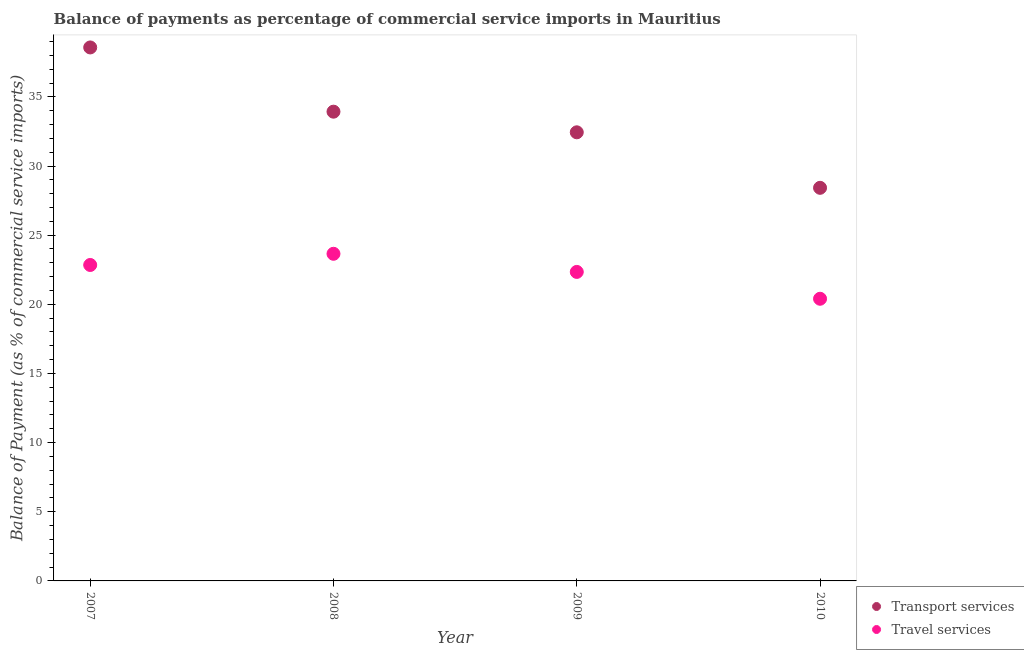How many different coloured dotlines are there?
Keep it short and to the point. 2. What is the balance of payments of travel services in 2008?
Provide a succinct answer. 23.65. Across all years, what is the maximum balance of payments of transport services?
Ensure brevity in your answer.  38.57. Across all years, what is the minimum balance of payments of transport services?
Your answer should be compact. 28.42. What is the total balance of payments of transport services in the graph?
Give a very brief answer. 133.36. What is the difference between the balance of payments of travel services in 2008 and that in 2009?
Offer a very short reply. 1.31. What is the difference between the balance of payments of travel services in 2007 and the balance of payments of transport services in 2008?
Keep it short and to the point. -11.08. What is the average balance of payments of transport services per year?
Keep it short and to the point. 33.34. In the year 2009, what is the difference between the balance of payments of travel services and balance of payments of transport services?
Give a very brief answer. -10.09. In how many years, is the balance of payments of transport services greater than 9 %?
Make the answer very short. 4. What is the ratio of the balance of payments of transport services in 2007 to that in 2009?
Make the answer very short. 1.19. What is the difference between the highest and the second highest balance of payments of travel services?
Keep it short and to the point. 0.81. What is the difference between the highest and the lowest balance of payments of travel services?
Provide a succinct answer. 3.25. In how many years, is the balance of payments of travel services greater than the average balance of payments of travel services taken over all years?
Offer a terse response. 3. How many dotlines are there?
Make the answer very short. 2. How many years are there in the graph?
Provide a succinct answer. 4. Are the values on the major ticks of Y-axis written in scientific E-notation?
Your response must be concise. No. How many legend labels are there?
Your answer should be compact. 2. How are the legend labels stacked?
Make the answer very short. Vertical. What is the title of the graph?
Offer a very short reply. Balance of payments as percentage of commercial service imports in Mauritius. Does "Methane" appear as one of the legend labels in the graph?
Your response must be concise. No. What is the label or title of the Y-axis?
Keep it short and to the point. Balance of Payment (as % of commercial service imports). What is the Balance of Payment (as % of commercial service imports) of Transport services in 2007?
Make the answer very short. 38.57. What is the Balance of Payment (as % of commercial service imports) in Travel services in 2007?
Ensure brevity in your answer.  22.84. What is the Balance of Payment (as % of commercial service imports) in Transport services in 2008?
Offer a terse response. 33.93. What is the Balance of Payment (as % of commercial service imports) of Travel services in 2008?
Ensure brevity in your answer.  23.65. What is the Balance of Payment (as % of commercial service imports) of Transport services in 2009?
Your answer should be very brief. 32.44. What is the Balance of Payment (as % of commercial service imports) of Travel services in 2009?
Provide a succinct answer. 22.34. What is the Balance of Payment (as % of commercial service imports) of Transport services in 2010?
Your response must be concise. 28.42. What is the Balance of Payment (as % of commercial service imports) in Travel services in 2010?
Offer a very short reply. 20.4. Across all years, what is the maximum Balance of Payment (as % of commercial service imports) in Transport services?
Your answer should be compact. 38.57. Across all years, what is the maximum Balance of Payment (as % of commercial service imports) in Travel services?
Your answer should be compact. 23.65. Across all years, what is the minimum Balance of Payment (as % of commercial service imports) of Transport services?
Offer a terse response. 28.42. Across all years, what is the minimum Balance of Payment (as % of commercial service imports) in Travel services?
Give a very brief answer. 20.4. What is the total Balance of Payment (as % of commercial service imports) in Transport services in the graph?
Your answer should be compact. 133.36. What is the total Balance of Payment (as % of commercial service imports) of Travel services in the graph?
Your answer should be compact. 89.24. What is the difference between the Balance of Payment (as % of commercial service imports) in Transport services in 2007 and that in 2008?
Ensure brevity in your answer.  4.64. What is the difference between the Balance of Payment (as % of commercial service imports) in Travel services in 2007 and that in 2008?
Give a very brief answer. -0.81. What is the difference between the Balance of Payment (as % of commercial service imports) in Transport services in 2007 and that in 2009?
Your answer should be very brief. 6.14. What is the difference between the Balance of Payment (as % of commercial service imports) in Travel services in 2007 and that in 2009?
Provide a short and direct response. 0.5. What is the difference between the Balance of Payment (as % of commercial service imports) of Transport services in 2007 and that in 2010?
Offer a very short reply. 10.15. What is the difference between the Balance of Payment (as % of commercial service imports) of Travel services in 2007 and that in 2010?
Ensure brevity in your answer.  2.44. What is the difference between the Balance of Payment (as % of commercial service imports) of Transport services in 2008 and that in 2009?
Make the answer very short. 1.49. What is the difference between the Balance of Payment (as % of commercial service imports) in Travel services in 2008 and that in 2009?
Offer a very short reply. 1.31. What is the difference between the Balance of Payment (as % of commercial service imports) of Transport services in 2008 and that in 2010?
Give a very brief answer. 5.51. What is the difference between the Balance of Payment (as % of commercial service imports) in Travel services in 2008 and that in 2010?
Provide a short and direct response. 3.25. What is the difference between the Balance of Payment (as % of commercial service imports) of Transport services in 2009 and that in 2010?
Your answer should be compact. 4.01. What is the difference between the Balance of Payment (as % of commercial service imports) of Travel services in 2009 and that in 2010?
Provide a short and direct response. 1.94. What is the difference between the Balance of Payment (as % of commercial service imports) in Transport services in 2007 and the Balance of Payment (as % of commercial service imports) in Travel services in 2008?
Provide a short and direct response. 14.92. What is the difference between the Balance of Payment (as % of commercial service imports) in Transport services in 2007 and the Balance of Payment (as % of commercial service imports) in Travel services in 2009?
Offer a terse response. 16.23. What is the difference between the Balance of Payment (as % of commercial service imports) of Transport services in 2007 and the Balance of Payment (as % of commercial service imports) of Travel services in 2010?
Offer a terse response. 18.17. What is the difference between the Balance of Payment (as % of commercial service imports) in Transport services in 2008 and the Balance of Payment (as % of commercial service imports) in Travel services in 2009?
Make the answer very short. 11.59. What is the difference between the Balance of Payment (as % of commercial service imports) of Transport services in 2008 and the Balance of Payment (as % of commercial service imports) of Travel services in 2010?
Give a very brief answer. 13.53. What is the difference between the Balance of Payment (as % of commercial service imports) in Transport services in 2009 and the Balance of Payment (as % of commercial service imports) in Travel services in 2010?
Offer a terse response. 12.04. What is the average Balance of Payment (as % of commercial service imports) of Transport services per year?
Your answer should be very brief. 33.34. What is the average Balance of Payment (as % of commercial service imports) in Travel services per year?
Your answer should be very brief. 22.31. In the year 2007, what is the difference between the Balance of Payment (as % of commercial service imports) in Transport services and Balance of Payment (as % of commercial service imports) in Travel services?
Provide a succinct answer. 15.73. In the year 2008, what is the difference between the Balance of Payment (as % of commercial service imports) of Transport services and Balance of Payment (as % of commercial service imports) of Travel services?
Keep it short and to the point. 10.28. In the year 2009, what is the difference between the Balance of Payment (as % of commercial service imports) in Transport services and Balance of Payment (as % of commercial service imports) in Travel services?
Give a very brief answer. 10.09. In the year 2010, what is the difference between the Balance of Payment (as % of commercial service imports) of Transport services and Balance of Payment (as % of commercial service imports) of Travel services?
Ensure brevity in your answer.  8.02. What is the ratio of the Balance of Payment (as % of commercial service imports) in Transport services in 2007 to that in 2008?
Ensure brevity in your answer.  1.14. What is the ratio of the Balance of Payment (as % of commercial service imports) of Travel services in 2007 to that in 2008?
Ensure brevity in your answer.  0.97. What is the ratio of the Balance of Payment (as % of commercial service imports) of Transport services in 2007 to that in 2009?
Give a very brief answer. 1.19. What is the ratio of the Balance of Payment (as % of commercial service imports) of Travel services in 2007 to that in 2009?
Provide a succinct answer. 1.02. What is the ratio of the Balance of Payment (as % of commercial service imports) in Transport services in 2007 to that in 2010?
Provide a short and direct response. 1.36. What is the ratio of the Balance of Payment (as % of commercial service imports) in Travel services in 2007 to that in 2010?
Provide a short and direct response. 1.12. What is the ratio of the Balance of Payment (as % of commercial service imports) of Transport services in 2008 to that in 2009?
Offer a terse response. 1.05. What is the ratio of the Balance of Payment (as % of commercial service imports) of Travel services in 2008 to that in 2009?
Provide a short and direct response. 1.06. What is the ratio of the Balance of Payment (as % of commercial service imports) in Transport services in 2008 to that in 2010?
Provide a short and direct response. 1.19. What is the ratio of the Balance of Payment (as % of commercial service imports) in Travel services in 2008 to that in 2010?
Make the answer very short. 1.16. What is the ratio of the Balance of Payment (as % of commercial service imports) in Transport services in 2009 to that in 2010?
Your response must be concise. 1.14. What is the ratio of the Balance of Payment (as % of commercial service imports) of Travel services in 2009 to that in 2010?
Ensure brevity in your answer.  1.1. What is the difference between the highest and the second highest Balance of Payment (as % of commercial service imports) of Transport services?
Your response must be concise. 4.64. What is the difference between the highest and the second highest Balance of Payment (as % of commercial service imports) in Travel services?
Make the answer very short. 0.81. What is the difference between the highest and the lowest Balance of Payment (as % of commercial service imports) of Transport services?
Keep it short and to the point. 10.15. What is the difference between the highest and the lowest Balance of Payment (as % of commercial service imports) of Travel services?
Provide a succinct answer. 3.25. 